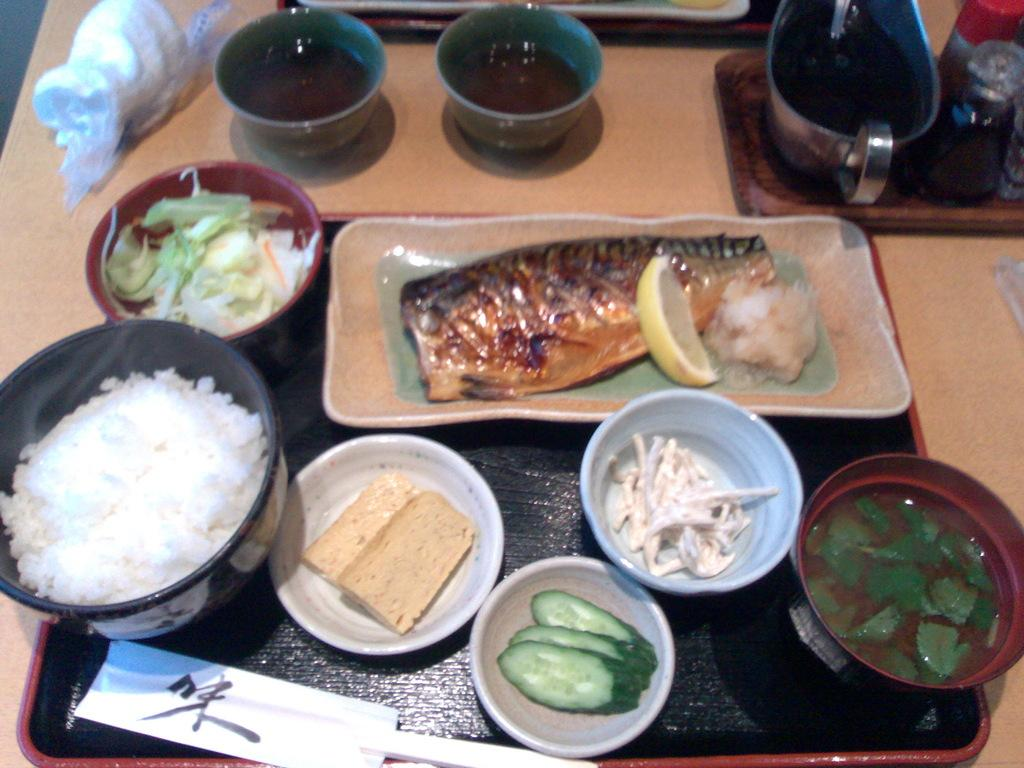What is the main piece of furniture in the image? There is a table in the image. What is placed on the table? There are trays on the table. What can be found inside the bowls on the table? There are bowls with items on the table. What is on the plates on the trays? There are plates with food items on the trays. What else can be found on the trays besides plates with food items? There are bowls with food items on the trays, as well as other unspecified items. How many spiders are crawling on the table in the image? There are no spiders present in the image. Where is the nearest market to the location of the image? The provided facts do not give any information about the location of the image, so it is impossible to determine the nearest market. 